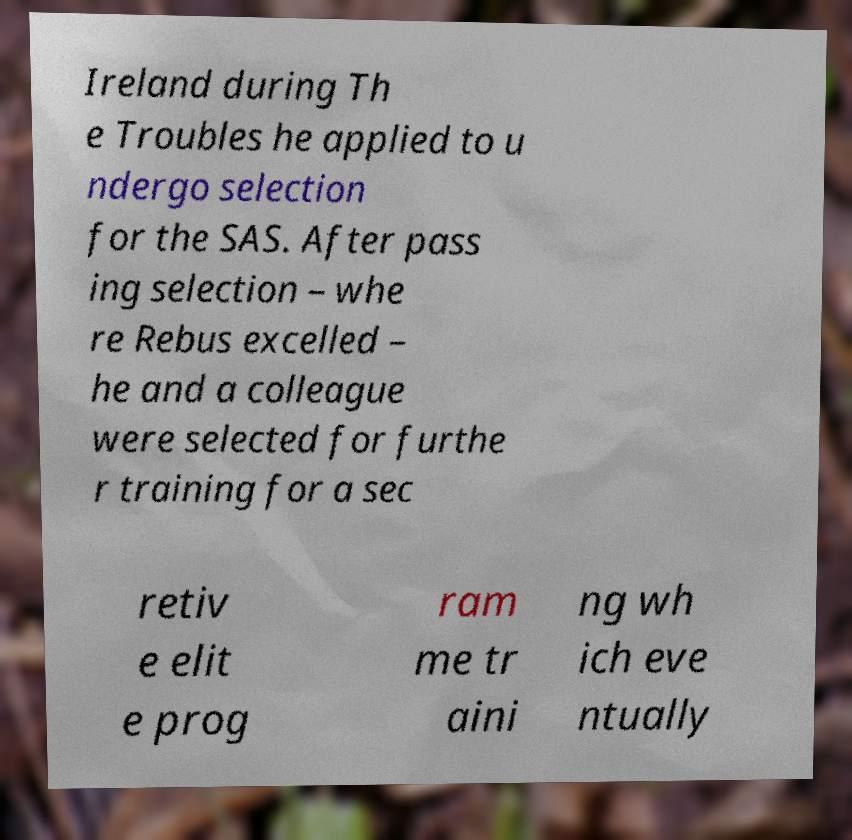Could you assist in decoding the text presented in this image and type it out clearly? Ireland during Th e Troubles he applied to u ndergo selection for the SAS. After pass ing selection – whe re Rebus excelled – he and a colleague were selected for furthe r training for a sec retiv e elit e prog ram me tr aini ng wh ich eve ntually 